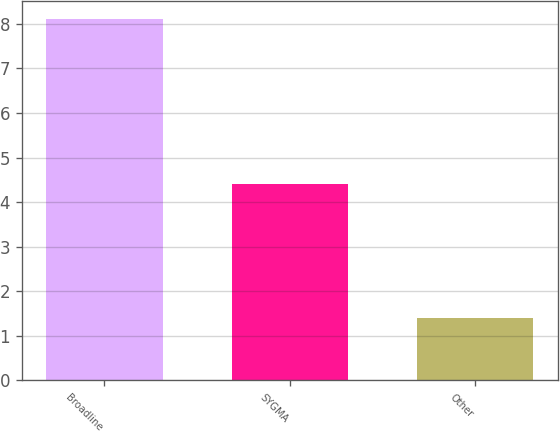Convert chart to OTSL. <chart><loc_0><loc_0><loc_500><loc_500><bar_chart><fcel>Broadline<fcel>SYGMA<fcel>Other<nl><fcel>8.1<fcel>4.4<fcel>1.4<nl></chart> 